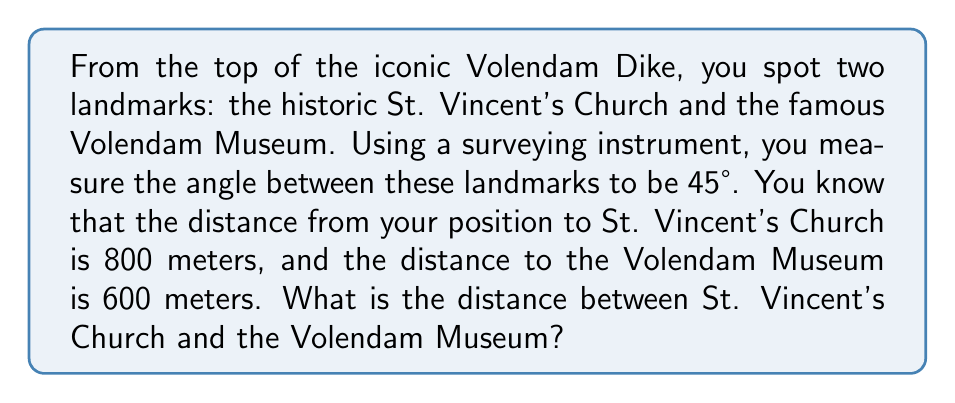Help me with this question. Let's approach this step-by-step using the law of cosines:

1) Let's define our variables:
   a = distance to St. Vincent's Church = 800 m
   b = distance to Volendam Museum = 600 m
   C = angle between the landmarks = 45° = π/4 radians
   c = distance between the landmarks (what we're solving for)

2) The law of cosines states:
   $$c^2 = a^2 + b^2 - 2ab \cos(C)$$

3) Let's substitute our known values:
   $$c^2 = 800^2 + 600^2 - 2(800)(600) \cos(45°)$$

4) Simplify:
   $$c^2 = 640,000 + 360,000 - 960,000 \cos(45°)$$

5) Calculate $\cos(45°)$:
   $$\cos(45°) = \frac{\sqrt{2}}{2} \approx 0.7071$$

6) Substitute this value:
   $$c^2 = 1,000,000 - 960,000(0.7071) \approx 320,178.4$$

7) Take the square root of both sides:
   $$c \approx \sqrt{320,178.4} \approx 565.84$$

Therefore, the distance between St. Vincent's Church and the Volendam Museum is approximately 565.84 meters.
Answer: 565.84 meters 